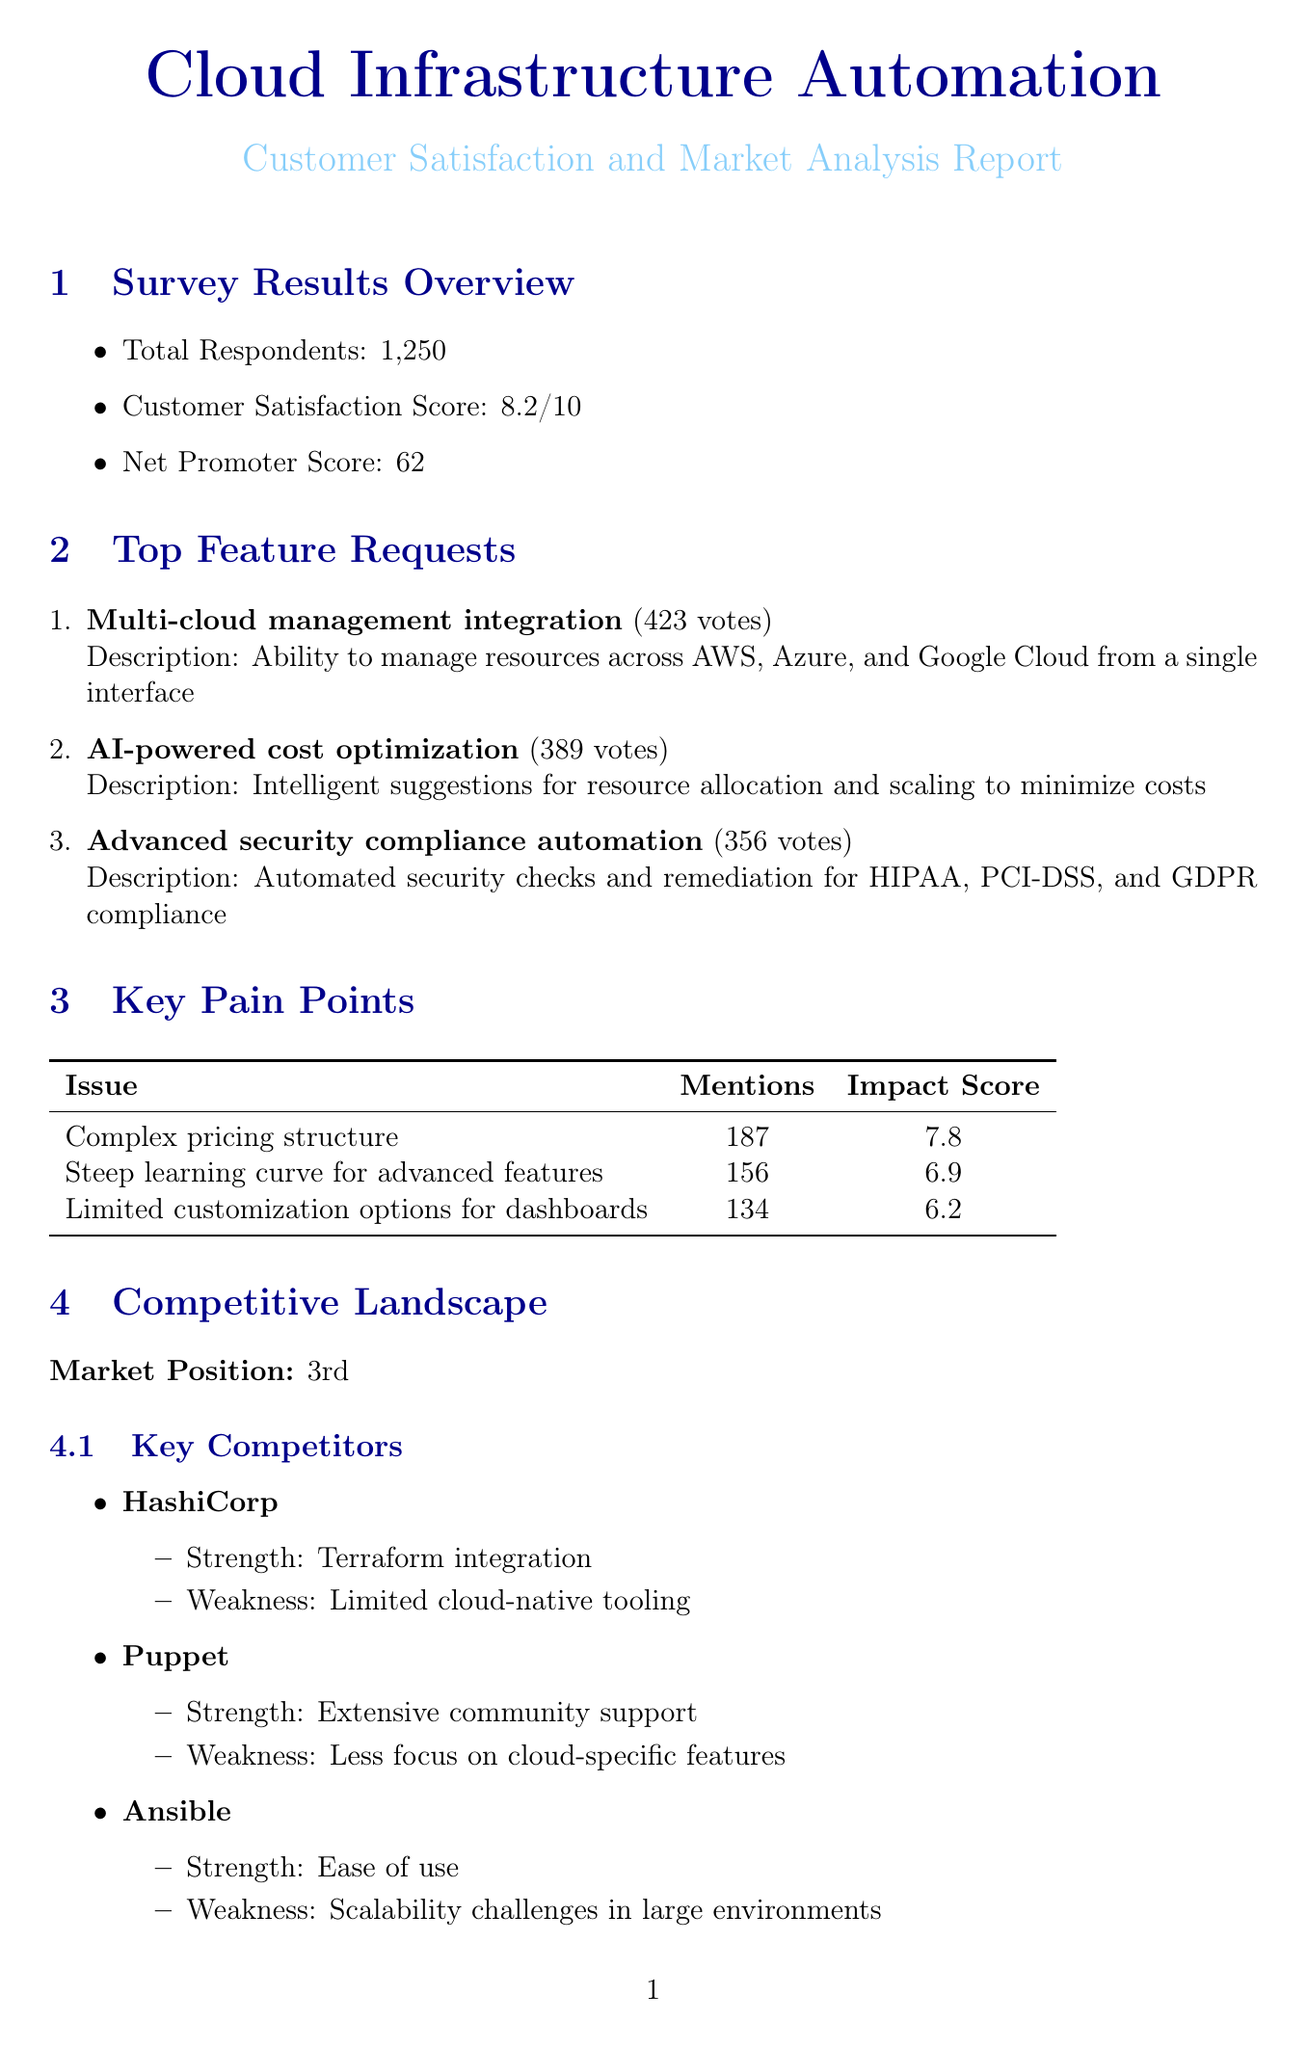What is the total number of respondents? The total number of respondents is stated explicitly in the document under the survey results section.
Answer: 1250 What is the customer satisfaction score? The customer satisfaction score is provided in the survey results section of the document.
Answer: 8.2 What is the most requested feature? The most requested feature is determined by the number of votes in the feature requests section.
Answer: Multi-cloud management integration How many votes did AI-powered cost optimization receive? The number of votes for AI-powered cost optimization is listed in the feature requests section.
Answer: 389 What is the impact score of the issue with the complex pricing structure? The impact score is explicitly mentioned next to the mention count for the complex pricing structure in the pain points section.
Answer: 7.8 Which competitor has a strength in Terraform integration? The competitor's strength is detailed in the competitive benchmarking section.
Answer: HashiCorp How many customer success stories are highlighted in the document? The number of customer success stories is counted in the customer success stories section.
Answer: 2 Which initiative has a planned release date in Q4 2023? The planned release date for initiatives is specified in the future roadmap priorities section of the document.
Answer: Green computing optimization What is one of the key differentiators listed for the service? Key differentiators are outlined in a specific section of the document.
Answer: Cloud-native architecture 